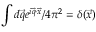<formula> <loc_0><loc_0><loc_500><loc_500>\int d \vec { q } e ^ { i \vec { q } \cdot \vec { x } } / 4 \pi ^ { 2 } = \delta ( \vec { x } )</formula> 